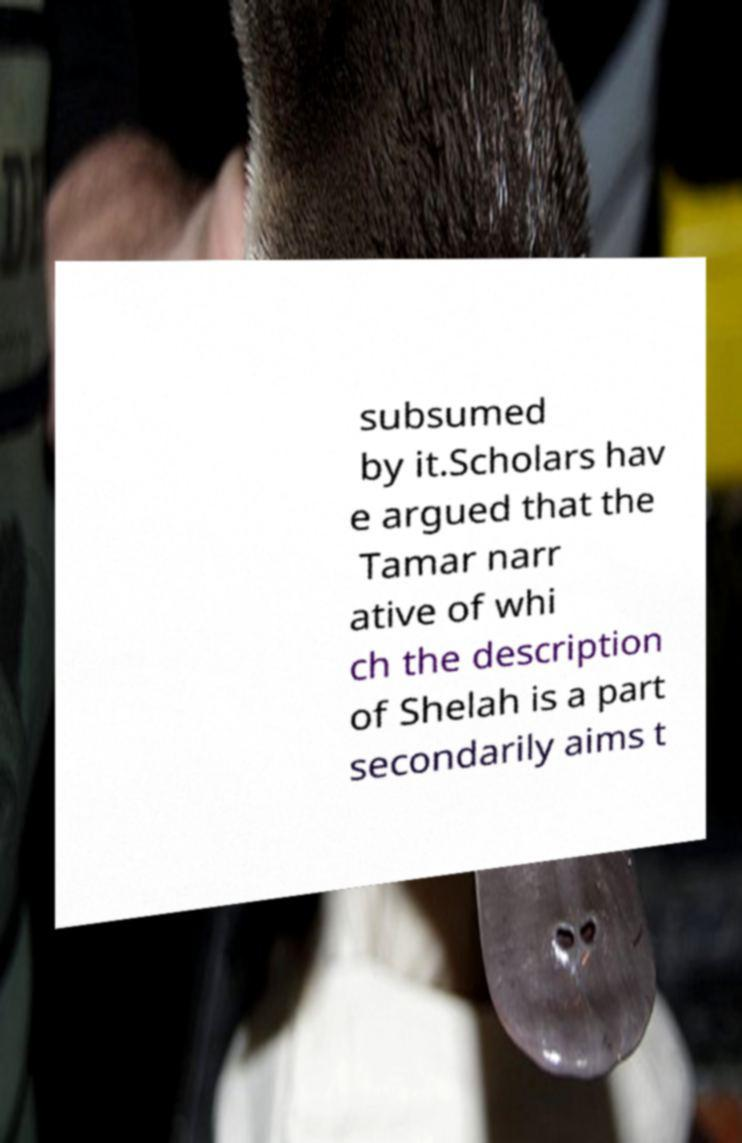Please read and relay the text visible in this image. What does it say? subsumed by it.Scholars hav e argued that the Tamar narr ative of whi ch the description of Shelah is a part secondarily aims t 